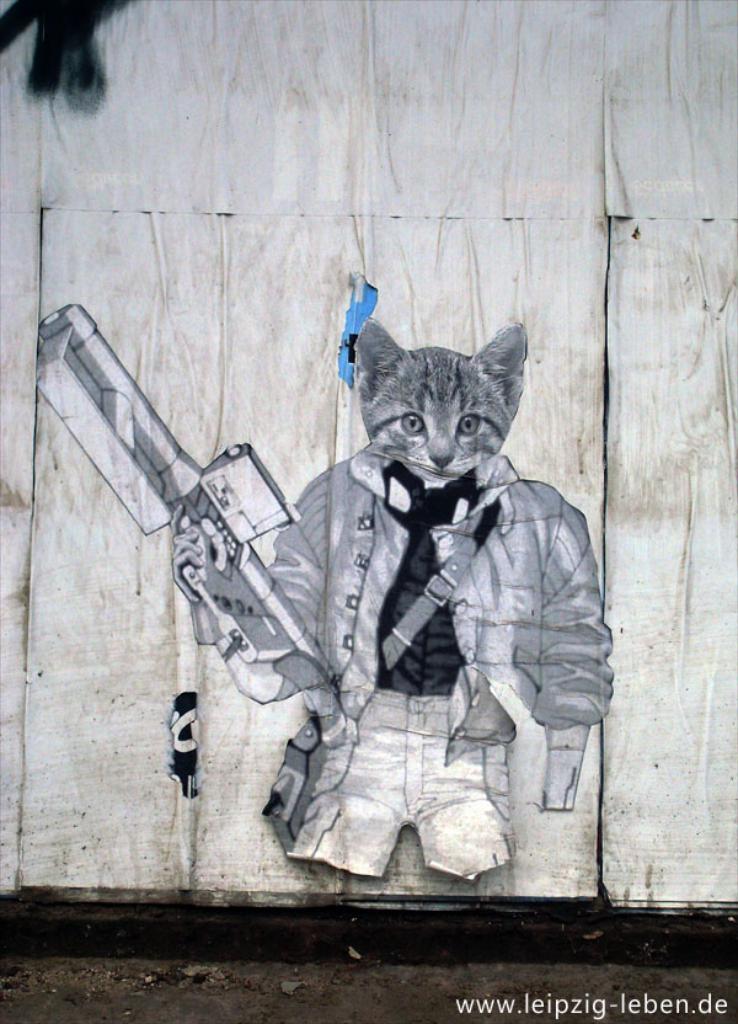Can you describe this image briefly? In this image we can see a sketch on the wall. At the bottom we can see the path and also the text. 